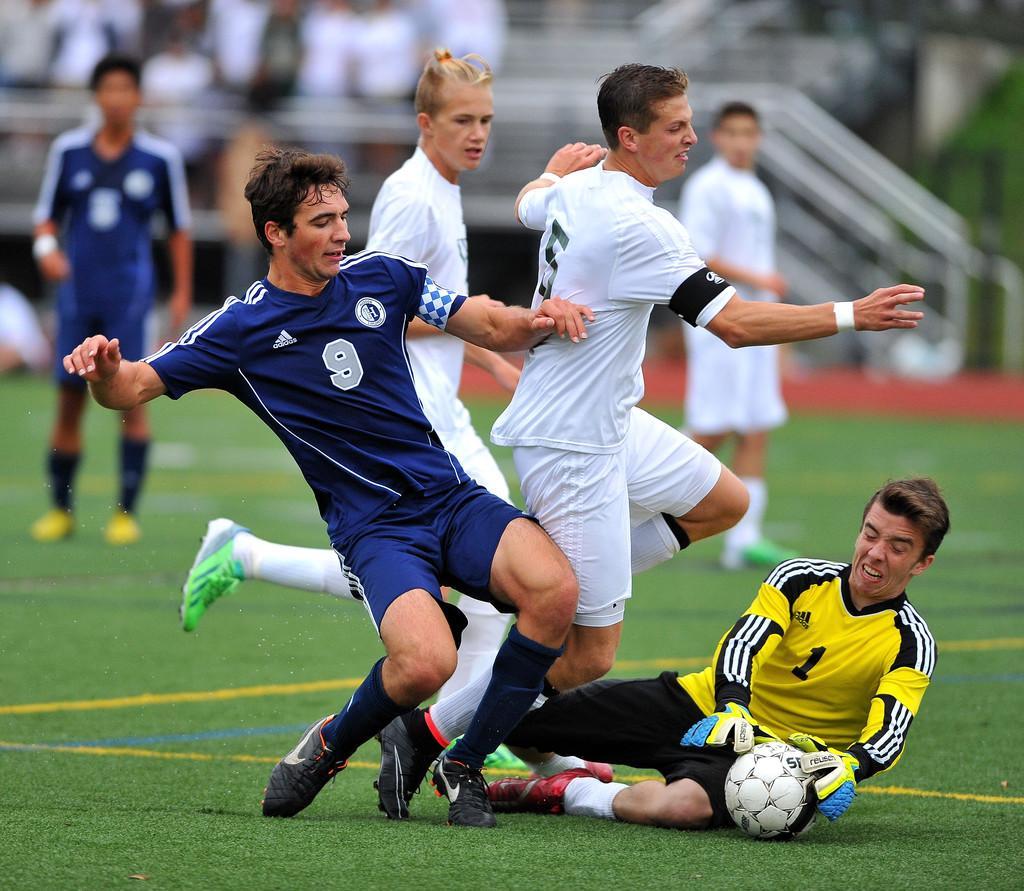Could you give a brief overview of what you see in this image? In this image I can see group of people playing game. In front the person is wearing blue color dress and I can see the blurred background. 